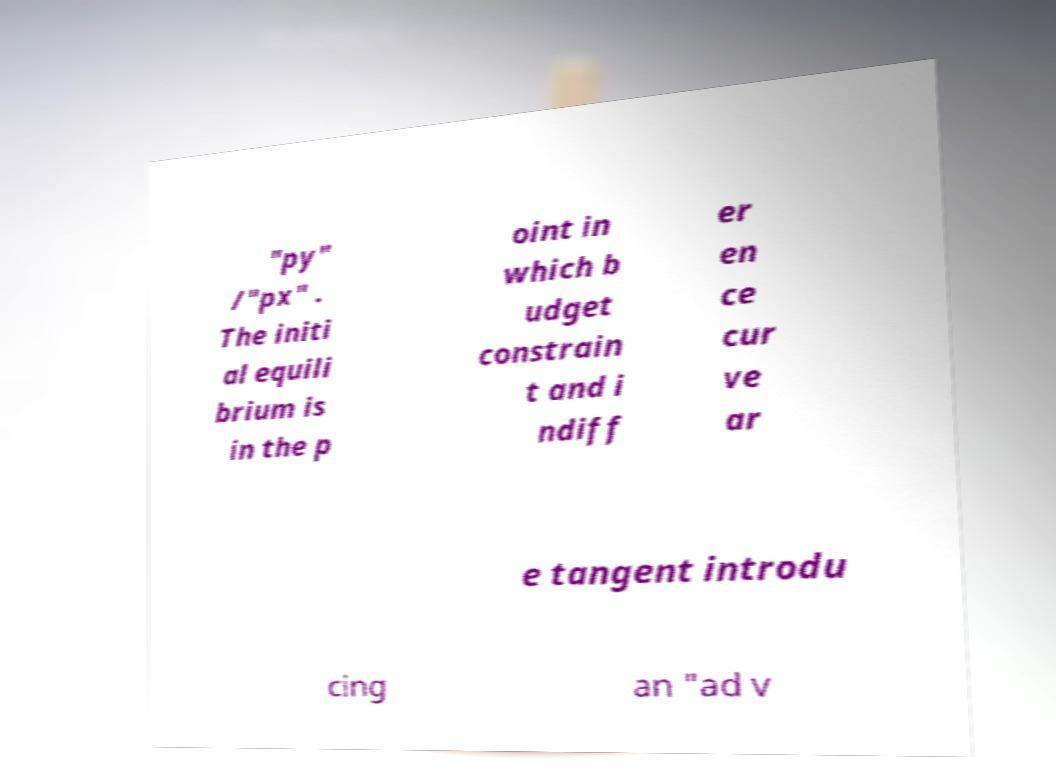Please identify and transcribe the text found in this image. "py" /"px" . The initi al equili brium is in the p oint in which b udget constrain t and i ndiff er en ce cur ve ar e tangent introdu cing an "ad v 